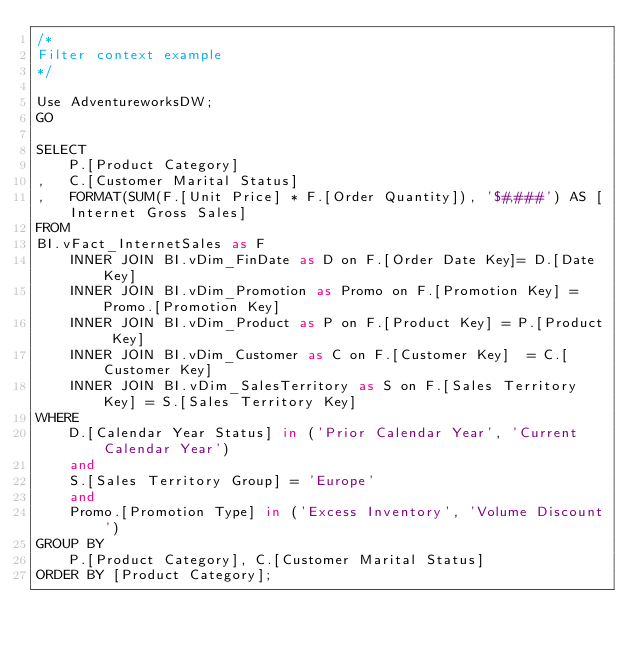Convert code to text. <code><loc_0><loc_0><loc_500><loc_500><_SQL_>/*
Filter context example
*/

Use AdventureworksDW;
GO

SELECT
	P.[Product Category]
,	C.[Customer Marital Status]
,	FORMAT(SUM(F.[Unit Price] * F.[Order Quantity]), '$#,###') AS [Internet Gross Sales]
FROM
BI.vFact_InternetSales as F
	INNER JOIN BI.vDim_FinDate as D on F.[Order Date Key]= D.[Date Key]
	INNER JOIN BI.vDim_Promotion as Promo on F.[Promotion Key] = Promo.[Promotion Key]
	INNER JOIN BI.vDim_Product as P on F.[Product Key] = P.[Product Key]
	INNER JOIN BI.vDim_Customer as C on F.[Customer Key]  = C.[Customer Key]
	INNER JOIN BI.vDim_SalesTerritory as S on F.[Sales Territory Key] = S.[Sales Territory Key]
WHERE 
	D.[Calendar Year Status] in ('Prior Calendar Year', 'Current Calendar Year')
	and
	S.[Sales Territory Group] = 'Europe'
	and
	Promo.[Promotion Type] in ('Excess Inventory', 'Volume Discount')
GROUP BY 
	P.[Product Category], C.[Customer Marital Status]
ORDER BY [Product Category];</code> 